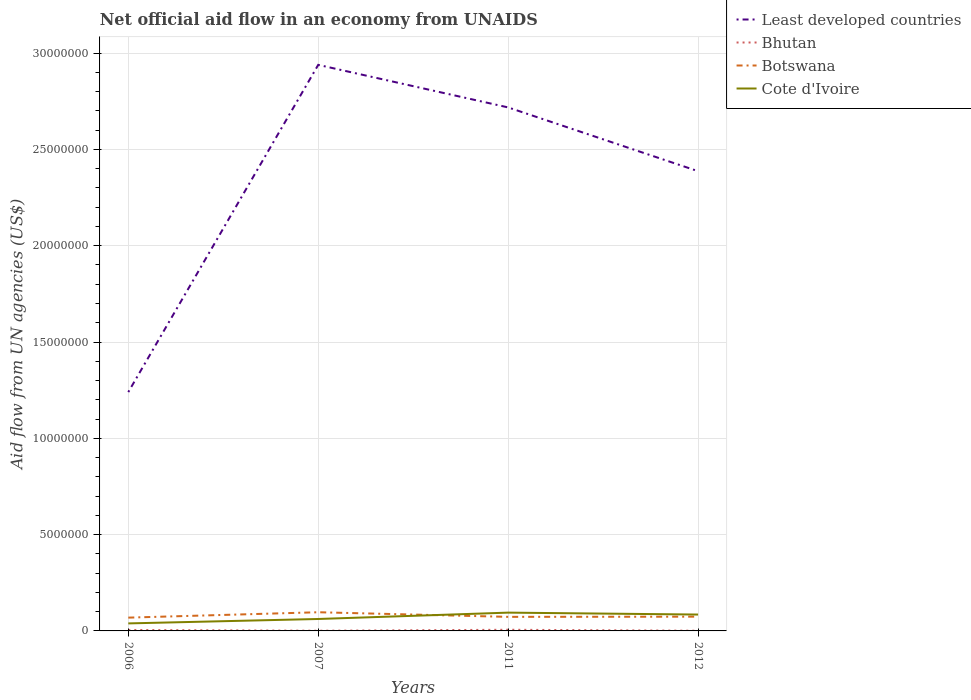Across all years, what is the maximum net official aid flow in Botswana?
Offer a very short reply. 6.90e+05. In which year was the net official aid flow in Bhutan maximum?
Make the answer very short. 2007. What is the total net official aid flow in Least developed countries in the graph?
Ensure brevity in your answer.  -1.48e+07. What is the difference between the highest and the second highest net official aid flow in Botswana?
Offer a very short reply. 2.80e+05. What is the difference between the highest and the lowest net official aid flow in Botswana?
Your response must be concise. 1. How many lines are there?
Provide a succinct answer. 4. What is the difference between two consecutive major ticks on the Y-axis?
Provide a succinct answer. 5.00e+06. Where does the legend appear in the graph?
Your response must be concise. Top right. How many legend labels are there?
Provide a succinct answer. 4. How are the legend labels stacked?
Provide a short and direct response. Vertical. What is the title of the graph?
Give a very brief answer. Net official aid flow in an economy from UNAIDS. Does "Tonga" appear as one of the legend labels in the graph?
Your answer should be compact. No. What is the label or title of the Y-axis?
Ensure brevity in your answer.  Aid flow from UN agencies (US$). What is the Aid flow from UN agencies (US$) in Least developed countries in 2006?
Ensure brevity in your answer.  1.24e+07. What is the Aid flow from UN agencies (US$) of Bhutan in 2006?
Make the answer very short. 5.00e+04. What is the Aid flow from UN agencies (US$) in Botswana in 2006?
Provide a short and direct response. 6.90e+05. What is the Aid flow from UN agencies (US$) of Least developed countries in 2007?
Ensure brevity in your answer.  2.94e+07. What is the Aid flow from UN agencies (US$) in Bhutan in 2007?
Provide a short and direct response. 10000. What is the Aid flow from UN agencies (US$) in Botswana in 2007?
Offer a terse response. 9.70e+05. What is the Aid flow from UN agencies (US$) in Cote d'Ivoire in 2007?
Keep it short and to the point. 6.20e+05. What is the Aid flow from UN agencies (US$) in Least developed countries in 2011?
Offer a terse response. 2.72e+07. What is the Aid flow from UN agencies (US$) of Bhutan in 2011?
Your answer should be compact. 6.00e+04. What is the Aid flow from UN agencies (US$) of Botswana in 2011?
Offer a terse response. 7.30e+05. What is the Aid flow from UN agencies (US$) of Cote d'Ivoire in 2011?
Ensure brevity in your answer.  9.50e+05. What is the Aid flow from UN agencies (US$) of Least developed countries in 2012?
Provide a succinct answer. 2.39e+07. What is the Aid flow from UN agencies (US$) in Bhutan in 2012?
Keep it short and to the point. 10000. What is the Aid flow from UN agencies (US$) in Botswana in 2012?
Offer a very short reply. 7.40e+05. What is the Aid flow from UN agencies (US$) of Cote d'Ivoire in 2012?
Provide a succinct answer. 8.50e+05. Across all years, what is the maximum Aid flow from UN agencies (US$) in Least developed countries?
Ensure brevity in your answer.  2.94e+07. Across all years, what is the maximum Aid flow from UN agencies (US$) in Bhutan?
Your answer should be compact. 6.00e+04. Across all years, what is the maximum Aid flow from UN agencies (US$) of Botswana?
Provide a short and direct response. 9.70e+05. Across all years, what is the maximum Aid flow from UN agencies (US$) of Cote d'Ivoire?
Give a very brief answer. 9.50e+05. Across all years, what is the minimum Aid flow from UN agencies (US$) of Least developed countries?
Your answer should be very brief. 1.24e+07. Across all years, what is the minimum Aid flow from UN agencies (US$) in Bhutan?
Provide a succinct answer. 10000. Across all years, what is the minimum Aid flow from UN agencies (US$) in Botswana?
Your response must be concise. 6.90e+05. What is the total Aid flow from UN agencies (US$) of Least developed countries in the graph?
Provide a short and direct response. 9.28e+07. What is the total Aid flow from UN agencies (US$) in Botswana in the graph?
Provide a short and direct response. 3.13e+06. What is the total Aid flow from UN agencies (US$) in Cote d'Ivoire in the graph?
Make the answer very short. 2.81e+06. What is the difference between the Aid flow from UN agencies (US$) in Least developed countries in 2006 and that in 2007?
Provide a short and direct response. -1.70e+07. What is the difference between the Aid flow from UN agencies (US$) of Bhutan in 2006 and that in 2007?
Ensure brevity in your answer.  4.00e+04. What is the difference between the Aid flow from UN agencies (US$) of Botswana in 2006 and that in 2007?
Provide a short and direct response. -2.80e+05. What is the difference between the Aid flow from UN agencies (US$) in Cote d'Ivoire in 2006 and that in 2007?
Your answer should be very brief. -2.30e+05. What is the difference between the Aid flow from UN agencies (US$) of Least developed countries in 2006 and that in 2011?
Your answer should be very brief. -1.48e+07. What is the difference between the Aid flow from UN agencies (US$) of Bhutan in 2006 and that in 2011?
Provide a succinct answer. -10000. What is the difference between the Aid flow from UN agencies (US$) of Cote d'Ivoire in 2006 and that in 2011?
Offer a very short reply. -5.60e+05. What is the difference between the Aid flow from UN agencies (US$) of Least developed countries in 2006 and that in 2012?
Your answer should be compact. -1.15e+07. What is the difference between the Aid flow from UN agencies (US$) in Cote d'Ivoire in 2006 and that in 2012?
Give a very brief answer. -4.60e+05. What is the difference between the Aid flow from UN agencies (US$) in Least developed countries in 2007 and that in 2011?
Keep it short and to the point. 2.21e+06. What is the difference between the Aid flow from UN agencies (US$) in Bhutan in 2007 and that in 2011?
Provide a short and direct response. -5.00e+04. What is the difference between the Aid flow from UN agencies (US$) in Cote d'Ivoire in 2007 and that in 2011?
Ensure brevity in your answer.  -3.30e+05. What is the difference between the Aid flow from UN agencies (US$) of Least developed countries in 2007 and that in 2012?
Ensure brevity in your answer.  5.52e+06. What is the difference between the Aid flow from UN agencies (US$) in Bhutan in 2007 and that in 2012?
Keep it short and to the point. 0. What is the difference between the Aid flow from UN agencies (US$) of Cote d'Ivoire in 2007 and that in 2012?
Provide a short and direct response. -2.30e+05. What is the difference between the Aid flow from UN agencies (US$) in Least developed countries in 2011 and that in 2012?
Your answer should be compact. 3.31e+06. What is the difference between the Aid flow from UN agencies (US$) of Botswana in 2011 and that in 2012?
Provide a short and direct response. -10000. What is the difference between the Aid flow from UN agencies (US$) of Least developed countries in 2006 and the Aid flow from UN agencies (US$) of Bhutan in 2007?
Keep it short and to the point. 1.24e+07. What is the difference between the Aid flow from UN agencies (US$) of Least developed countries in 2006 and the Aid flow from UN agencies (US$) of Botswana in 2007?
Provide a short and direct response. 1.14e+07. What is the difference between the Aid flow from UN agencies (US$) in Least developed countries in 2006 and the Aid flow from UN agencies (US$) in Cote d'Ivoire in 2007?
Your answer should be very brief. 1.18e+07. What is the difference between the Aid flow from UN agencies (US$) of Bhutan in 2006 and the Aid flow from UN agencies (US$) of Botswana in 2007?
Offer a terse response. -9.20e+05. What is the difference between the Aid flow from UN agencies (US$) in Bhutan in 2006 and the Aid flow from UN agencies (US$) in Cote d'Ivoire in 2007?
Keep it short and to the point. -5.70e+05. What is the difference between the Aid flow from UN agencies (US$) in Least developed countries in 2006 and the Aid flow from UN agencies (US$) in Bhutan in 2011?
Give a very brief answer. 1.23e+07. What is the difference between the Aid flow from UN agencies (US$) of Least developed countries in 2006 and the Aid flow from UN agencies (US$) of Botswana in 2011?
Your answer should be compact. 1.17e+07. What is the difference between the Aid flow from UN agencies (US$) of Least developed countries in 2006 and the Aid flow from UN agencies (US$) of Cote d'Ivoire in 2011?
Your answer should be very brief. 1.14e+07. What is the difference between the Aid flow from UN agencies (US$) of Bhutan in 2006 and the Aid flow from UN agencies (US$) of Botswana in 2011?
Provide a succinct answer. -6.80e+05. What is the difference between the Aid flow from UN agencies (US$) of Bhutan in 2006 and the Aid flow from UN agencies (US$) of Cote d'Ivoire in 2011?
Provide a succinct answer. -9.00e+05. What is the difference between the Aid flow from UN agencies (US$) in Least developed countries in 2006 and the Aid flow from UN agencies (US$) in Bhutan in 2012?
Make the answer very short. 1.24e+07. What is the difference between the Aid flow from UN agencies (US$) in Least developed countries in 2006 and the Aid flow from UN agencies (US$) in Botswana in 2012?
Your answer should be compact. 1.17e+07. What is the difference between the Aid flow from UN agencies (US$) in Least developed countries in 2006 and the Aid flow from UN agencies (US$) in Cote d'Ivoire in 2012?
Give a very brief answer. 1.16e+07. What is the difference between the Aid flow from UN agencies (US$) in Bhutan in 2006 and the Aid flow from UN agencies (US$) in Botswana in 2012?
Give a very brief answer. -6.90e+05. What is the difference between the Aid flow from UN agencies (US$) of Bhutan in 2006 and the Aid flow from UN agencies (US$) of Cote d'Ivoire in 2012?
Your answer should be compact. -8.00e+05. What is the difference between the Aid flow from UN agencies (US$) of Botswana in 2006 and the Aid flow from UN agencies (US$) of Cote d'Ivoire in 2012?
Your answer should be compact. -1.60e+05. What is the difference between the Aid flow from UN agencies (US$) in Least developed countries in 2007 and the Aid flow from UN agencies (US$) in Bhutan in 2011?
Your response must be concise. 2.93e+07. What is the difference between the Aid flow from UN agencies (US$) of Least developed countries in 2007 and the Aid flow from UN agencies (US$) of Botswana in 2011?
Make the answer very short. 2.87e+07. What is the difference between the Aid flow from UN agencies (US$) of Least developed countries in 2007 and the Aid flow from UN agencies (US$) of Cote d'Ivoire in 2011?
Make the answer very short. 2.84e+07. What is the difference between the Aid flow from UN agencies (US$) of Bhutan in 2007 and the Aid flow from UN agencies (US$) of Botswana in 2011?
Ensure brevity in your answer.  -7.20e+05. What is the difference between the Aid flow from UN agencies (US$) in Bhutan in 2007 and the Aid flow from UN agencies (US$) in Cote d'Ivoire in 2011?
Give a very brief answer. -9.40e+05. What is the difference between the Aid flow from UN agencies (US$) in Botswana in 2007 and the Aid flow from UN agencies (US$) in Cote d'Ivoire in 2011?
Provide a succinct answer. 2.00e+04. What is the difference between the Aid flow from UN agencies (US$) of Least developed countries in 2007 and the Aid flow from UN agencies (US$) of Bhutan in 2012?
Keep it short and to the point. 2.94e+07. What is the difference between the Aid flow from UN agencies (US$) in Least developed countries in 2007 and the Aid flow from UN agencies (US$) in Botswana in 2012?
Provide a succinct answer. 2.86e+07. What is the difference between the Aid flow from UN agencies (US$) in Least developed countries in 2007 and the Aid flow from UN agencies (US$) in Cote d'Ivoire in 2012?
Ensure brevity in your answer.  2.85e+07. What is the difference between the Aid flow from UN agencies (US$) of Bhutan in 2007 and the Aid flow from UN agencies (US$) of Botswana in 2012?
Your response must be concise. -7.30e+05. What is the difference between the Aid flow from UN agencies (US$) in Bhutan in 2007 and the Aid flow from UN agencies (US$) in Cote d'Ivoire in 2012?
Your answer should be very brief. -8.40e+05. What is the difference between the Aid flow from UN agencies (US$) of Botswana in 2007 and the Aid flow from UN agencies (US$) of Cote d'Ivoire in 2012?
Your answer should be compact. 1.20e+05. What is the difference between the Aid flow from UN agencies (US$) of Least developed countries in 2011 and the Aid flow from UN agencies (US$) of Bhutan in 2012?
Provide a succinct answer. 2.72e+07. What is the difference between the Aid flow from UN agencies (US$) of Least developed countries in 2011 and the Aid flow from UN agencies (US$) of Botswana in 2012?
Make the answer very short. 2.64e+07. What is the difference between the Aid flow from UN agencies (US$) in Least developed countries in 2011 and the Aid flow from UN agencies (US$) in Cote d'Ivoire in 2012?
Offer a very short reply. 2.63e+07. What is the difference between the Aid flow from UN agencies (US$) in Bhutan in 2011 and the Aid flow from UN agencies (US$) in Botswana in 2012?
Your answer should be very brief. -6.80e+05. What is the difference between the Aid flow from UN agencies (US$) in Bhutan in 2011 and the Aid flow from UN agencies (US$) in Cote d'Ivoire in 2012?
Give a very brief answer. -7.90e+05. What is the average Aid flow from UN agencies (US$) of Least developed countries per year?
Offer a terse response. 2.32e+07. What is the average Aid flow from UN agencies (US$) of Bhutan per year?
Your answer should be compact. 3.25e+04. What is the average Aid flow from UN agencies (US$) in Botswana per year?
Your response must be concise. 7.82e+05. What is the average Aid flow from UN agencies (US$) in Cote d'Ivoire per year?
Your answer should be compact. 7.02e+05. In the year 2006, what is the difference between the Aid flow from UN agencies (US$) of Least developed countries and Aid flow from UN agencies (US$) of Bhutan?
Ensure brevity in your answer.  1.24e+07. In the year 2006, what is the difference between the Aid flow from UN agencies (US$) in Least developed countries and Aid flow from UN agencies (US$) in Botswana?
Offer a very short reply. 1.17e+07. In the year 2006, what is the difference between the Aid flow from UN agencies (US$) in Least developed countries and Aid flow from UN agencies (US$) in Cote d'Ivoire?
Make the answer very short. 1.20e+07. In the year 2006, what is the difference between the Aid flow from UN agencies (US$) of Bhutan and Aid flow from UN agencies (US$) of Botswana?
Make the answer very short. -6.40e+05. In the year 2006, what is the difference between the Aid flow from UN agencies (US$) of Bhutan and Aid flow from UN agencies (US$) of Cote d'Ivoire?
Provide a succinct answer. -3.40e+05. In the year 2007, what is the difference between the Aid flow from UN agencies (US$) of Least developed countries and Aid flow from UN agencies (US$) of Bhutan?
Provide a succinct answer. 2.94e+07. In the year 2007, what is the difference between the Aid flow from UN agencies (US$) in Least developed countries and Aid flow from UN agencies (US$) in Botswana?
Provide a short and direct response. 2.84e+07. In the year 2007, what is the difference between the Aid flow from UN agencies (US$) of Least developed countries and Aid flow from UN agencies (US$) of Cote d'Ivoire?
Provide a short and direct response. 2.88e+07. In the year 2007, what is the difference between the Aid flow from UN agencies (US$) in Bhutan and Aid flow from UN agencies (US$) in Botswana?
Offer a very short reply. -9.60e+05. In the year 2007, what is the difference between the Aid flow from UN agencies (US$) of Bhutan and Aid flow from UN agencies (US$) of Cote d'Ivoire?
Your answer should be very brief. -6.10e+05. In the year 2011, what is the difference between the Aid flow from UN agencies (US$) in Least developed countries and Aid flow from UN agencies (US$) in Bhutan?
Provide a succinct answer. 2.71e+07. In the year 2011, what is the difference between the Aid flow from UN agencies (US$) in Least developed countries and Aid flow from UN agencies (US$) in Botswana?
Your answer should be compact. 2.64e+07. In the year 2011, what is the difference between the Aid flow from UN agencies (US$) of Least developed countries and Aid flow from UN agencies (US$) of Cote d'Ivoire?
Provide a succinct answer. 2.62e+07. In the year 2011, what is the difference between the Aid flow from UN agencies (US$) of Bhutan and Aid flow from UN agencies (US$) of Botswana?
Give a very brief answer. -6.70e+05. In the year 2011, what is the difference between the Aid flow from UN agencies (US$) in Bhutan and Aid flow from UN agencies (US$) in Cote d'Ivoire?
Offer a very short reply. -8.90e+05. In the year 2012, what is the difference between the Aid flow from UN agencies (US$) in Least developed countries and Aid flow from UN agencies (US$) in Bhutan?
Ensure brevity in your answer.  2.39e+07. In the year 2012, what is the difference between the Aid flow from UN agencies (US$) of Least developed countries and Aid flow from UN agencies (US$) of Botswana?
Your answer should be compact. 2.31e+07. In the year 2012, what is the difference between the Aid flow from UN agencies (US$) of Least developed countries and Aid flow from UN agencies (US$) of Cote d'Ivoire?
Ensure brevity in your answer.  2.30e+07. In the year 2012, what is the difference between the Aid flow from UN agencies (US$) in Bhutan and Aid flow from UN agencies (US$) in Botswana?
Offer a very short reply. -7.30e+05. In the year 2012, what is the difference between the Aid flow from UN agencies (US$) of Bhutan and Aid flow from UN agencies (US$) of Cote d'Ivoire?
Offer a very short reply. -8.40e+05. What is the ratio of the Aid flow from UN agencies (US$) of Least developed countries in 2006 to that in 2007?
Your answer should be compact. 0.42. What is the ratio of the Aid flow from UN agencies (US$) of Bhutan in 2006 to that in 2007?
Ensure brevity in your answer.  5. What is the ratio of the Aid flow from UN agencies (US$) in Botswana in 2006 to that in 2007?
Ensure brevity in your answer.  0.71. What is the ratio of the Aid flow from UN agencies (US$) of Cote d'Ivoire in 2006 to that in 2007?
Your answer should be compact. 0.63. What is the ratio of the Aid flow from UN agencies (US$) in Least developed countries in 2006 to that in 2011?
Offer a very short reply. 0.46. What is the ratio of the Aid flow from UN agencies (US$) in Bhutan in 2006 to that in 2011?
Provide a succinct answer. 0.83. What is the ratio of the Aid flow from UN agencies (US$) of Botswana in 2006 to that in 2011?
Give a very brief answer. 0.95. What is the ratio of the Aid flow from UN agencies (US$) of Cote d'Ivoire in 2006 to that in 2011?
Provide a short and direct response. 0.41. What is the ratio of the Aid flow from UN agencies (US$) in Least developed countries in 2006 to that in 2012?
Offer a terse response. 0.52. What is the ratio of the Aid flow from UN agencies (US$) of Bhutan in 2006 to that in 2012?
Ensure brevity in your answer.  5. What is the ratio of the Aid flow from UN agencies (US$) in Botswana in 2006 to that in 2012?
Your answer should be very brief. 0.93. What is the ratio of the Aid flow from UN agencies (US$) in Cote d'Ivoire in 2006 to that in 2012?
Give a very brief answer. 0.46. What is the ratio of the Aid flow from UN agencies (US$) in Least developed countries in 2007 to that in 2011?
Offer a terse response. 1.08. What is the ratio of the Aid flow from UN agencies (US$) in Bhutan in 2007 to that in 2011?
Your answer should be compact. 0.17. What is the ratio of the Aid flow from UN agencies (US$) in Botswana in 2007 to that in 2011?
Your answer should be compact. 1.33. What is the ratio of the Aid flow from UN agencies (US$) of Cote d'Ivoire in 2007 to that in 2011?
Your response must be concise. 0.65. What is the ratio of the Aid flow from UN agencies (US$) of Least developed countries in 2007 to that in 2012?
Your answer should be very brief. 1.23. What is the ratio of the Aid flow from UN agencies (US$) of Botswana in 2007 to that in 2012?
Your response must be concise. 1.31. What is the ratio of the Aid flow from UN agencies (US$) of Cote d'Ivoire in 2007 to that in 2012?
Offer a very short reply. 0.73. What is the ratio of the Aid flow from UN agencies (US$) of Least developed countries in 2011 to that in 2012?
Give a very brief answer. 1.14. What is the ratio of the Aid flow from UN agencies (US$) of Botswana in 2011 to that in 2012?
Provide a succinct answer. 0.99. What is the ratio of the Aid flow from UN agencies (US$) of Cote d'Ivoire in 2011 to that in 2012?
Offer a terse response. 1.12. What is the difference between the highest and the second highest Aid flow from UN agencies (US$) of Least developed countries?
Your answer should be very brief. 2.21e+06. What is the difference between the highest and the second highest Aid flow from UN agencies (US$) in Bhutan?
Make the answer very short. 10000. What is the difference between the highest and the second highest Aid flow from UN agencies (US$) in Cote d'Ivoire?
Make the answer very short. 1.00e+05. What is the difference between the highest and the lowest Aid flow from UN agencies (US$) in Least developed countries?
Provide a short and direct response. 1.70e+07. What is the difference between the highest and the lowest Aid flow from UN agencies (US$) in Cote d'Ivoire?
Make the answer very short. 5.60e+05. 